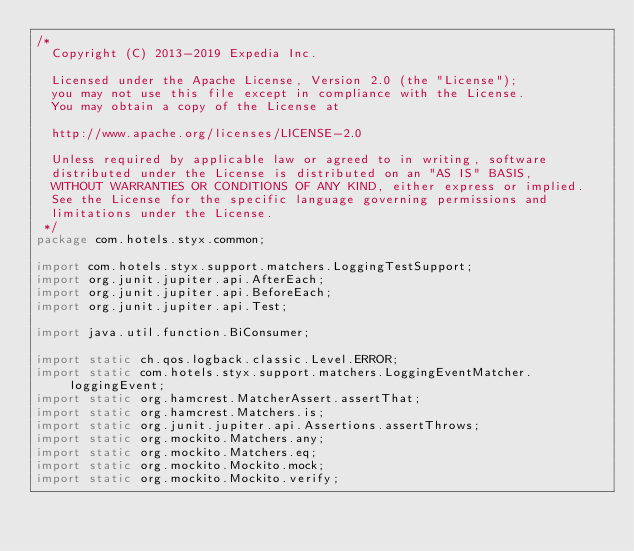<code> <loc_0><loc_0><loc_500><loc_500><_Java_>/*
  Copyright (C) 2013-2019 Expedia Inc.

  Licensed under the Apache License, Version 2.0 (the "License");
  you may not use this file except in compliance with the License.
  You may obtain a copy of the License at

  http://www.apache.org/licenses/LICENSE-2.0

  Unless required by applicable law or agreed to in writing, software
  distributed under the License is distributed on an "AS IS" BASIS,
  WITHOUT WARRANTIES OR CONDITIONS OF ANY KIND, either express or implied.
  See the License for the specific language governing permissions and
  limitations under the License.
 */
package com.hotels.styx.common;

import com.hotels.styx.support.matchers.LoggingTestSupport;
import org.junit.jupiter.api.AfterEach;
import org.junit.jupiter.api.BeforeEach;
import org.junit.jupiter.api.Test;

import java.util.function.BiConsumer;

import static ch.qos.logback.classic.Level.ERROR;
import static com.hotels.styx.support.matchers.LoggingEventMatcher.loggingEvent;
import static org.hamcrest.MatcherAssert.assertThat;
import static org.hamcrest.Matchers.is;
import static org.junit.jupiter.api.Assertions.assertThrows;
import static org.mockito.Matchers.any;
import static org.mockito.Matchers.eq;
import static org.mockito.Mockito.mock;
import static org.mockito.Mockito.verify;
</code> 